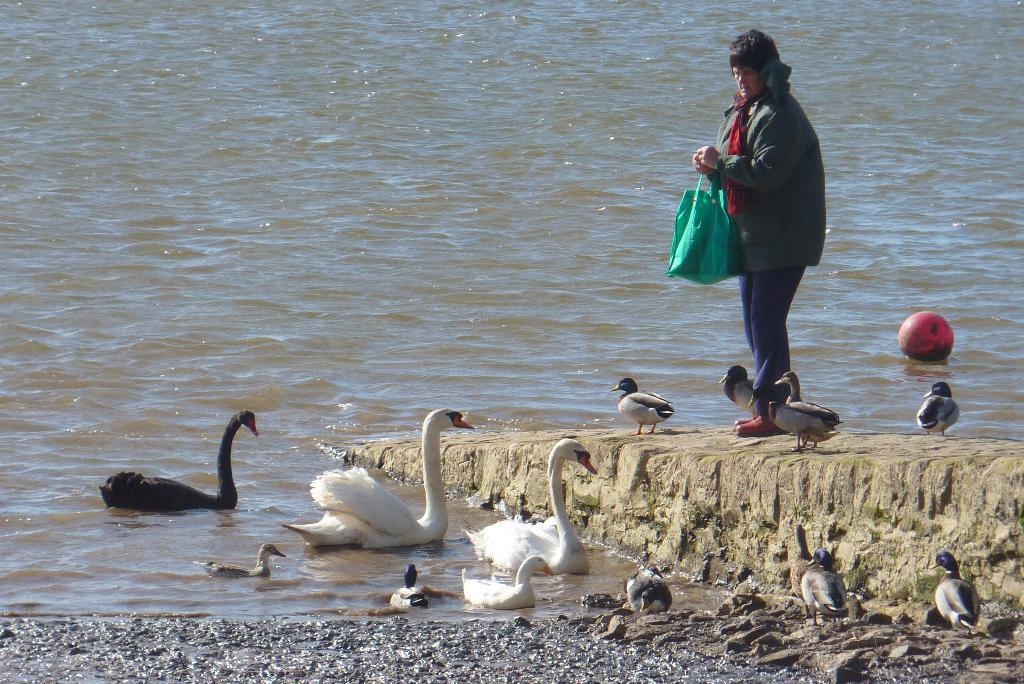What is the woman in the image doing? The woman is standing in the image and holding a bag. Can you describe the objects or animals at the bottom of the image? There is a ball at the bottom of the image. What type of birds are present in the water in the image? There are swans on the water in the image. What type of birds are present on the floor and ground in the image? There are ducks on the floor and on the ground in the image. Where is the cave located in the image? There is no cave present in the image. What type of geese can be seen in the image? There are no geese present in the image; it features swans and ducks. 